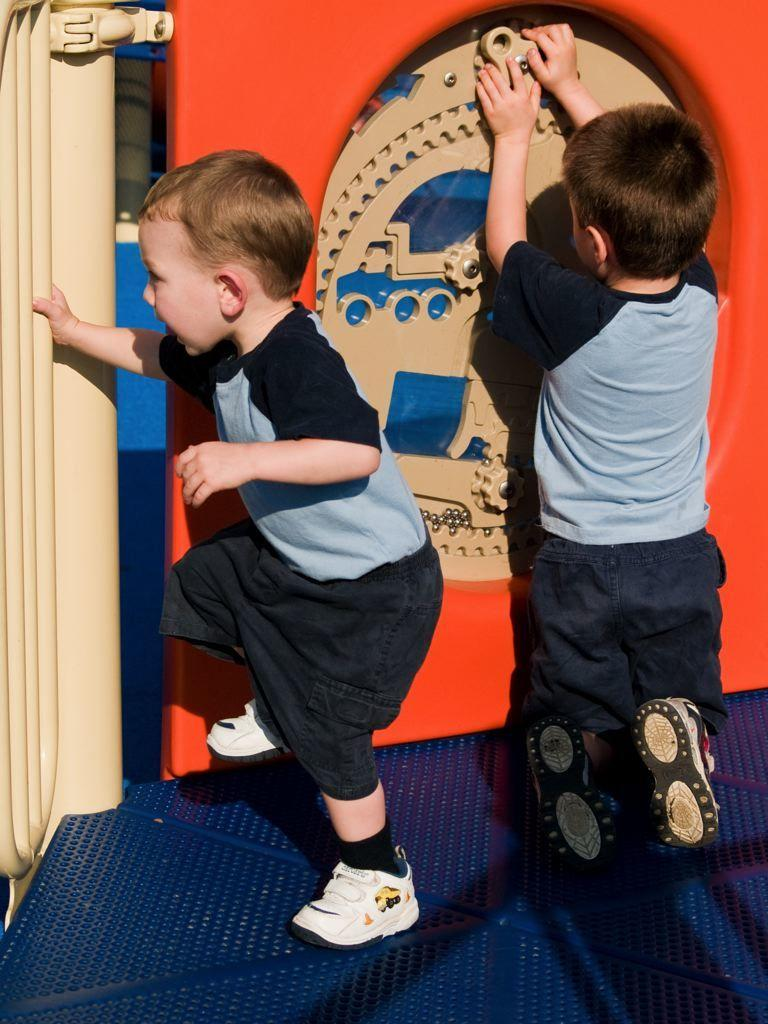How many boys are in the image? There are two boys in the center of the image. What are the boys doing in the image? The boys are playing. What can be seen in the background of the image? There is a wall and other objects in the background of the image. What is visible at the bottom of the image? The floor is visible at the bottom of the image. What type of meat can be seen hanging from the wall in the image? There is no meat present in the image; the wall is in the background and does not have any meat hanging from it. 